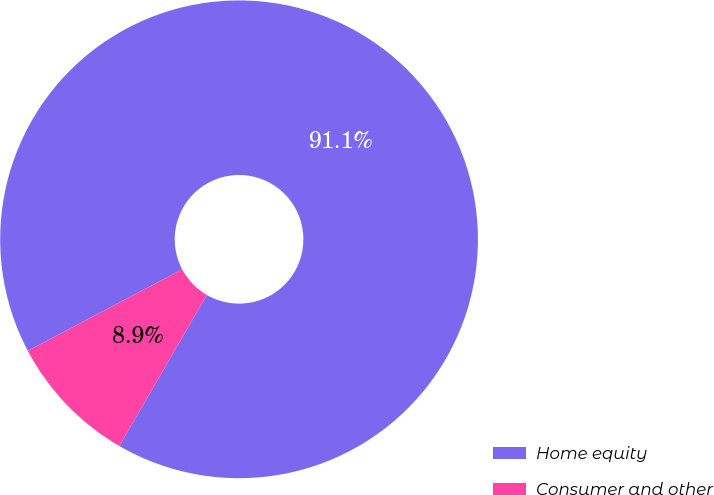<chart> <loc_0><loc_0><loc_500><loc_500><pie_chart><fcel>Home equity<fcel>Consumer and other<nl><fcel>91.09%<fcel>8.91%<nl></chart> 